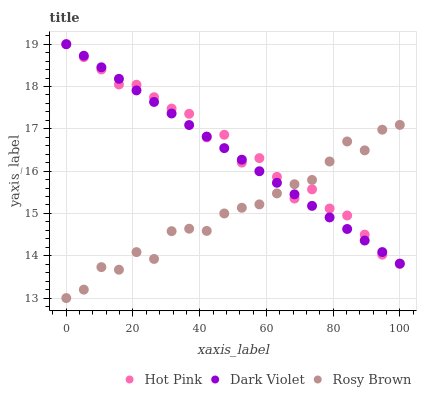Does Rosy Brown have the minimum area under the curve?
Answer yes or no. Yes. Does Hot Pink have the maximum area under the curve?
Answer yes or no. Yes. Does Dark Violet have the minimum area under the curve?
Answer yes or no. No. Does Dark Violet have the maximum area under the curve?
Answer yes or no. No. Is Dark Violet the smoothest?
Answer yes or no. Yes. Is Rosy Brown the roughest?
Answer yes or no. Yes. Is Hot Pink the smoothest?
Answer yes or no. No. Is Hot Pink the roughest?
Answer yes or no. No. Does Rosy Brown have the lowest value?
Answer yes or no. Yes. Does Hot Pink have the lowest value?
Answer yes or no. No. Does Dark Violet have the highest value?
Answer yes or no. Yes. Does Dark Violet intersect Hot Pink?
Answer yes or no. Yes. Is Dark Violet less than Hot Pink?
Answer yes or no. No. Is Dark Violet greater than Hot Pink?
Answer yes or no. No. 